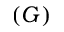<formula> <loc_0><loc_0><loc_500><loc_500>( G )</formula> 